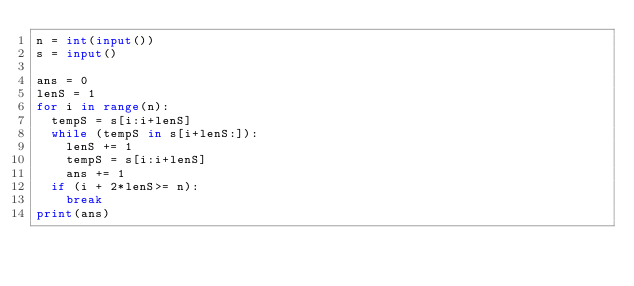<code> <loc_0><loc_0><loc_500><loc_500><_Python_>n = int(input())
s = input()

ans = 0
lenS = 1
for i in range(n):
	tempS = s[i:i+lenS]
	while (tempS in s[i+lenS:]):
		lenS += 1
		tempS = s[i:i+lenS]
		ans += 1
	if (i + 2*lenS>= n):
		break
print(ans)</code> 